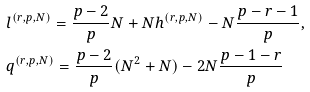<formula> <loc_0><loc_0><loc_500><loc_500>& l ^ { ( r , p , N ) } = \frac { p - 2 } { p } N + N h ^ { ( r , p , N ) } - N \frac { p - r - 1 } { p } , \\ & q ^ { ( r , p , N ) } = \frac { p - 2 } { p } ( N ^ { 2 } + N ) - 2 N \frac { p - 1 - r } { p }</formula> 